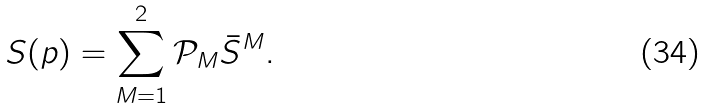<formula> <loc_0><loc_0><loc_500><loc_500>S ( p ) = \sum _ { M = 1 } ^ { 2 } \mathcal { P } _ { M } \bar { S } ^ { M } .</formula> 